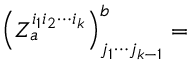<formula> <loc_0><loc_0><loc_500><loc_500>\left ( Z _ { a } ^ { i _ { 1 } i _ { 2 } \cdots i _ { k } } \right ) _ { j _ { 1 } \cdots j _ { k - 1 } } ^ { b } =</formula> 